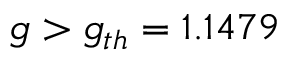Convert formula to latex. <formula><loc_0><loc_0><loc_500><loc_500>g > g _ { t h } = 1 . 1 4 7 9</formula> 